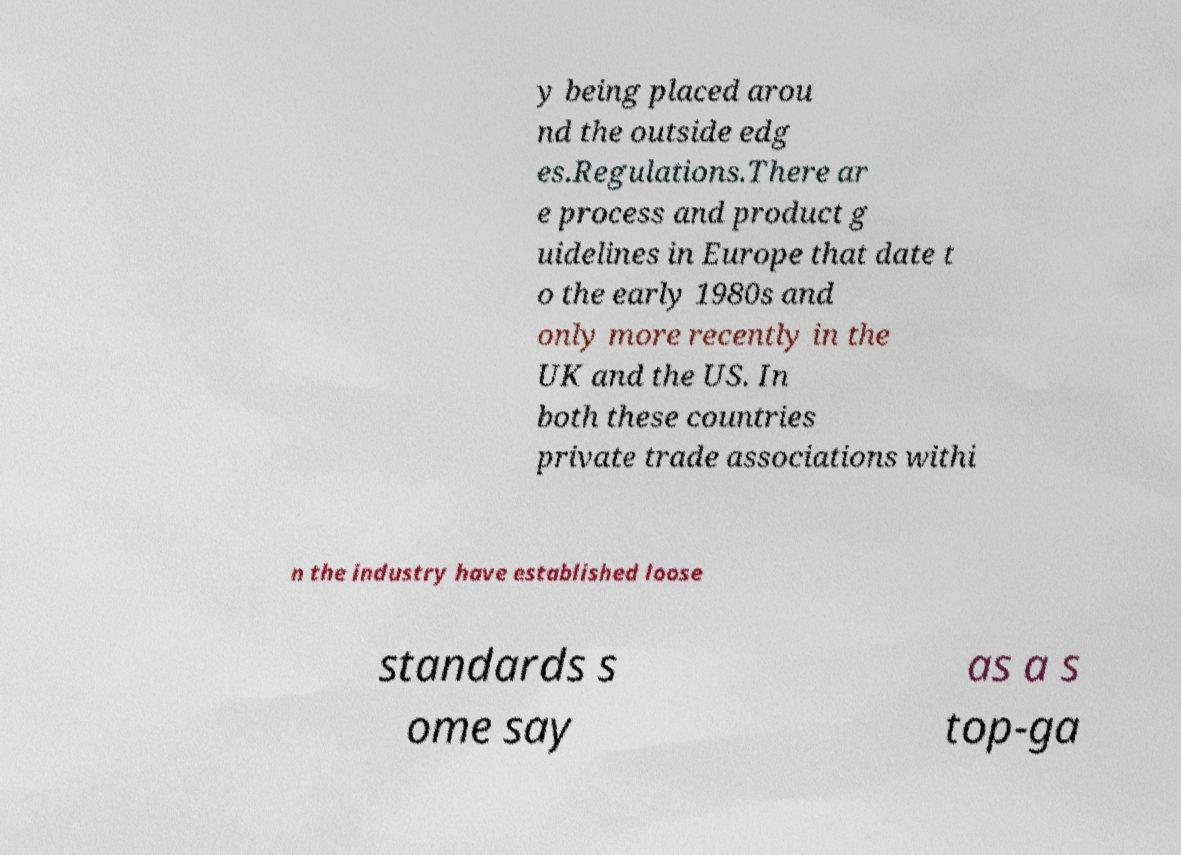Can you accurately transcribe the text from the provided image for me? y being placed arou nd the outside edg es.Regulations.There ar e process and product g uidelines in Europe that date t o the early 1980s and only more recently in the UK and the US. In both these countries private trade associations withi n the industry have established loose standards s ome say as a s top-ga 